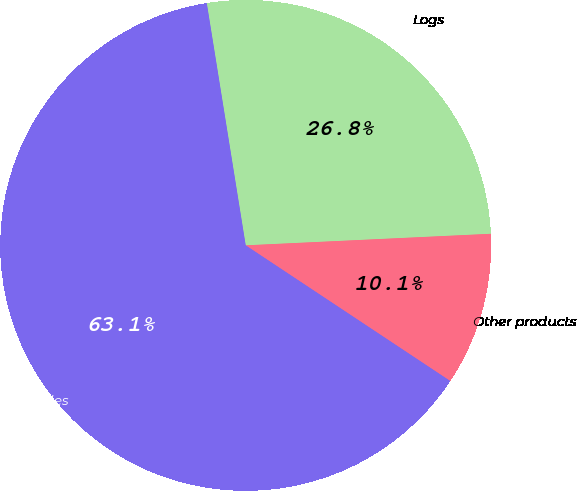Convert chart. <chart><loc_0><loc_0><loc_500><loc_500><pie_chart><fcel>Logs<fcel>Other products<fcel>Intersegment sales<nl><fcel>26.79%<fcel>10.07%<fcel>63.15%<nl></chart> 